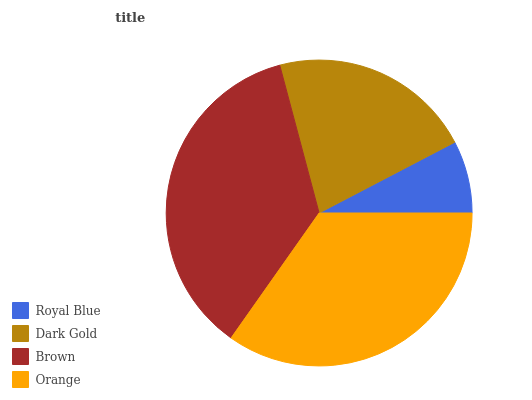Is Royal Blue the minimum?
Answer yes or no. Yes. Is Brown the maximum?
Answer yes or no. Yes. Is Dark Gold the minimum?
Answer yes or no. No. Is Dark Gold the maximum?
Answer yes or no. No. Is Dark Gold greater than Royal Blue?
Answer yes or no. Yes. Is Royal Blue less than Dark Gold?
Answer yes or no. Yes. Is Royal Blue greater than Dark Gold?
Answer yes or no. No. Is Dark Gold less than Royal Blue?
Answer yes or no. No. Is Orange the high median?
Answer yes or no. Yes. Is Dark Gold the low median?
Answer yes or no. Yes. Is Royal Blue the high median?
Answer yes or no. No. Is Brown the low median?
Answer yes or no. No. 